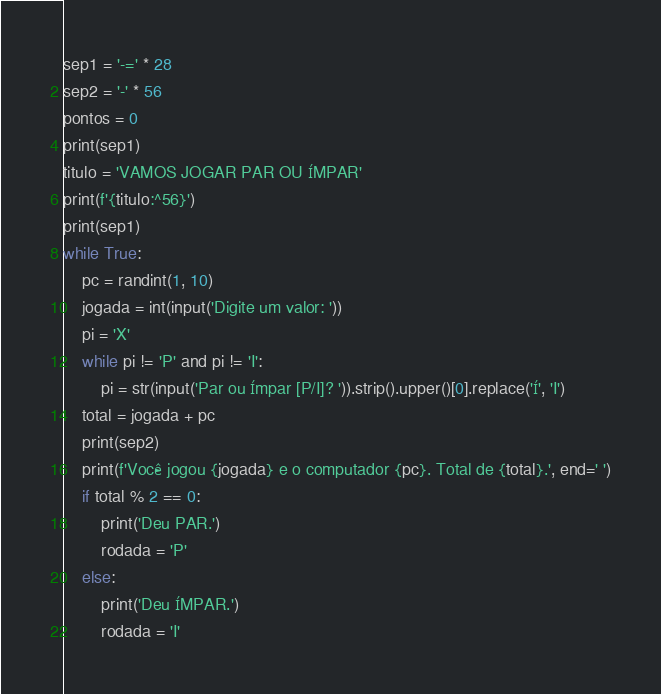Convert code to text. <code><loc_0><loc_0><loc_500><loc_500><_Python_>sep1 = '-=' * 28
sep2 = '-' * 56
pontos = 0
print(sep1)
titulo = 'VAMOS JOGAR PAR OU ÍMPAR'
print(f'{titulo:^56}')
print(sep1)
while True:
    pc = randint(1, 10)
    jogada = int(input('Digite um valor: '))
    pi = 'X'
    while pi != 'P' and pi != 'I':
        pi = str(input('Par ou Ímpar [P/I]? ')).strip().upper()[0].replace('Í', 'I')
    total = jogada + pc
    print(sep2)
    print(f'Você jogou {jogada} e o computador {pc}. Total de {total}.', end=' ')
    if total % 2 == 0:
        print('Deu PAR.')
        rodada = 'P'
    else:
        print('Deu ÍMPAR.')
        rodada = 'I'</code> 